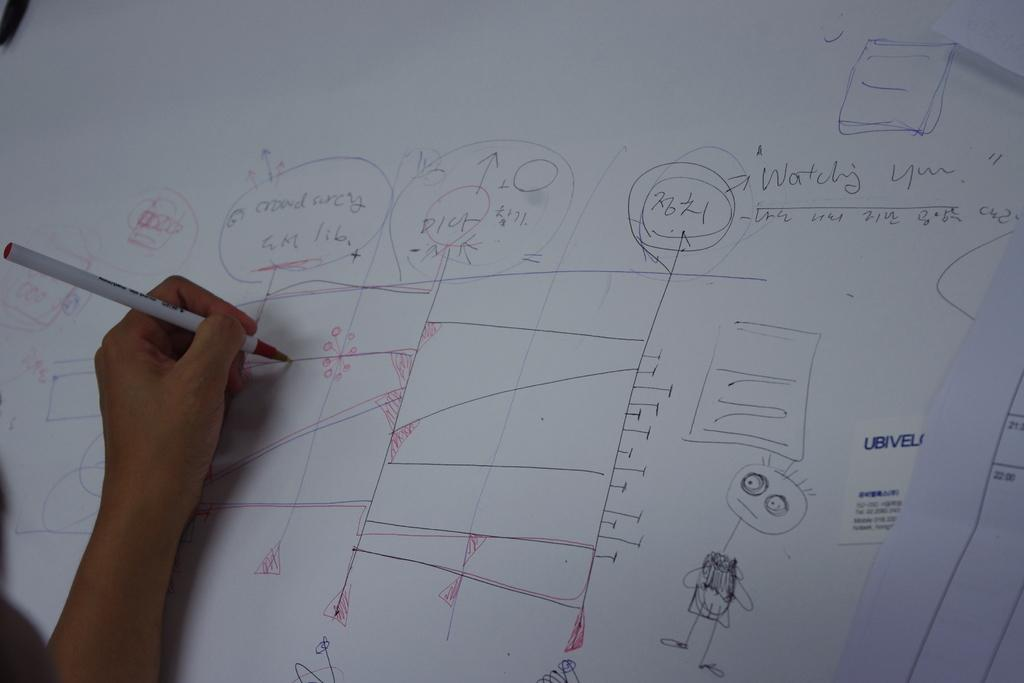<image>
Describe the image concisely. a white board with the words Watching You on it 